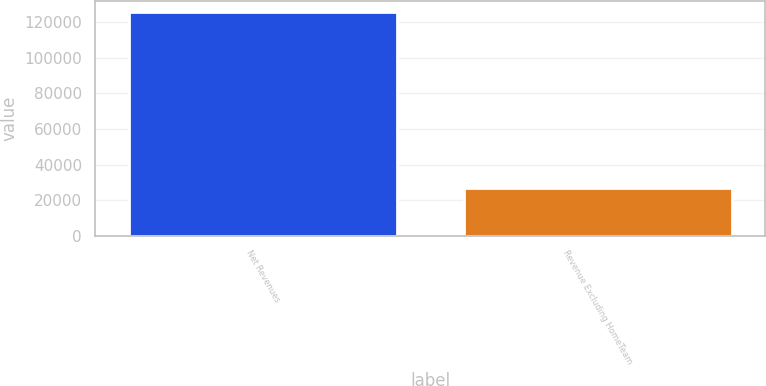Convert chart. <chart><loc_0><loc_0><loc_500><loc_500><bar_chart><fcel>Net Revenues<fcel>Revenue Excluding HomeTeam<nl><fcel>125644<fcel>26713<nl></chart> 